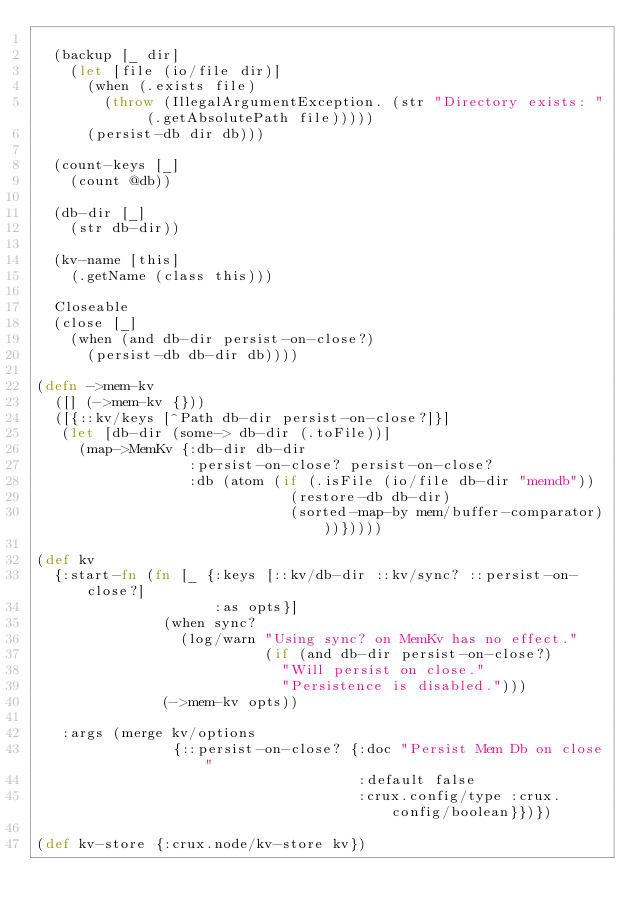<code> <loc_0><loc_0><loc_500><loc_500><_Clojure_>
  (backup [_ dir]
    (let [file (io/file dir)]
      (when (.exists file)
        (throw (IllegalArgumentException. (str "Directory exists: " (.getAbsolutePath file)))))
      (persist-db dir db)))

  (count-keys [_]
    (count @db))

  (db-dir [_]
    (str db-dir))

  (kv-name [this]
    (.getName (class this)))

  Closeable
  (close [_]
    (when (and db-dir persist-on-close?)
      (persist-db db-dir db))))

(defn ->mem-kv
  ([] (->mem-kv {}))
  ([{::kv/keys [^Path db-dir persist-on-close?]}]
   (let [db-dir (some-> db-dir (.toFile))]
     (map->MemKv {:db-dir db-dir
                  :persist-on-close? persist-on-close?
                  :db (atom (if (.isFile (io/file db-dir "memdb"))
                              (restore-db db-dir)
                              (sorted-map-by mem/buffer-comparator)))}))))

(def kv
  {:start-fn (fn [_ {:keys [::kv/db-dir ::kv/sync? ::persist-on-close?]
                     :as opts}]
               (when sync?
                 (log/warn "Using sync? on MemKv has no effect."
                           (if (and db-dir persist-on-close?)
                             "Will persist on close."
                             "Persistence is disabled.")))
               (->mem-kv opts))

   :args (merge kv/options
                {::persist-on-close? {:doc "Persist Mem Db on close"
                                      :default false
                                      :crux.config/type :crux.config/boolean}})})

(def kv-store {:crux.node/kv-store kv})
</code> 